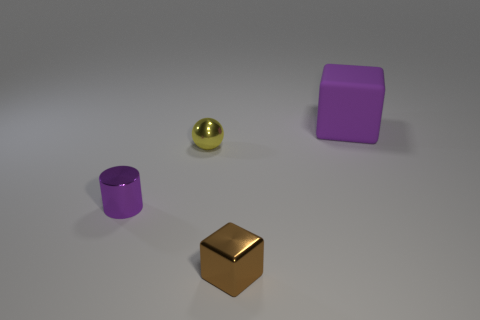Is the shape of the tiny metallic thing that is in front of the small purple object the same as the thing to the right of the small block?
Give a very brief answer. Yes. There is another object that is the same shape as the small brown thing; what is its material?
Ensure brevity in your answer.  Rubber. What is the color of the thing that is both on the right side of the tiny yellow metal ball and to the left of the large rubber cube?
Provide a short and direct response. Brown. There is a thing that is right of the block that is to the left of the large purple thing; are there any yellow shiny objects that are on the right side of it?
Make the answer very short. No. What number of objects are either small shiny objects or small gray rubber objects?
Your answer should be compact. 3. Is the material of the brown thing the same as the purple object that is on the left side of the big matte object?
Your response must be concise. Yes. Is there anything else that has the same color as the small metal cylinder?
Your answer should be compact. Yes. How many things are purple objects that are in front of the small yellow metallic object or purple objects that are left of the purple matte block?
Your answer should be compact. 1. There is a thing that is right of the small yellow metallic thing and left of the large cube; what is its shape?
Provide a succinct answer. Cube. There is a tiny object that is behind the cylinder; how many small purple objects are behind it?
Provide a short and direct response. 0. 